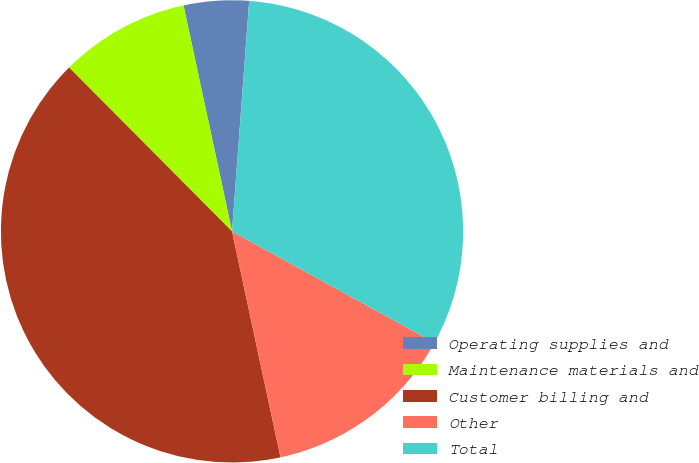Convert chart. <chart><loc_0><loc_0><loc_500><loc_500><pie_chart><fcel>Operating supplies and<fcel>Maintenance materials and<fcel>Customer billing and<fcel>Other<fcel>Total<nl><fcel>4.55%<fcel>9.09%<fcel>40.91%<fcel>13.64%<fcel>31.82%<nl></chart> 